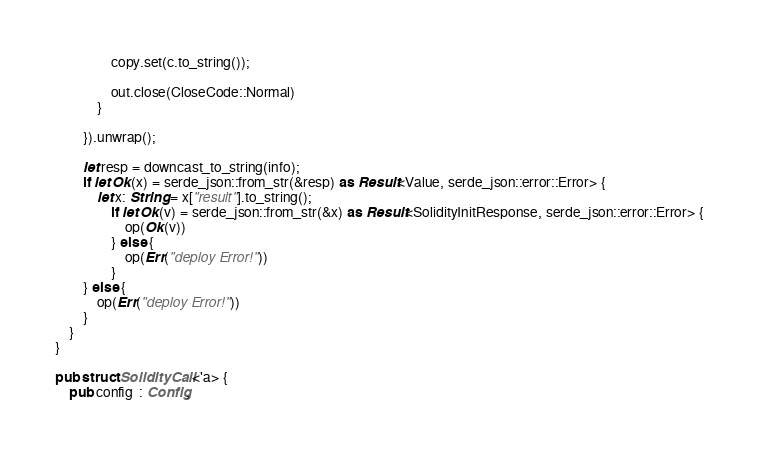Convert code to text. <code><loc_0><loc_0><loc_500><loc_500><_Rust_>                copy.set(c.to_string());

                out.close(CloseCode::Normal)
            }

        }).unwrap();

        let resp = downcast_to_string(info);
        if let Ok(x) = serde_json::from_str(&resp) as Result<Value, serde_json::error::Error> {
            let x: String = x["result"].to_string();
                if let Ok(v) = serde_json::from_str(&x) as Result<SolidityInitResponse, serde_json::error::Error> {
                    op(Ok(v))
                } else {
                    op(Err("deploy Error!"))
                }
        } else {
            op(Err("deploy Error!"))
        }
    }
}

pub struct SolidityCall <'a> {
    pub config  : Config,</code> 